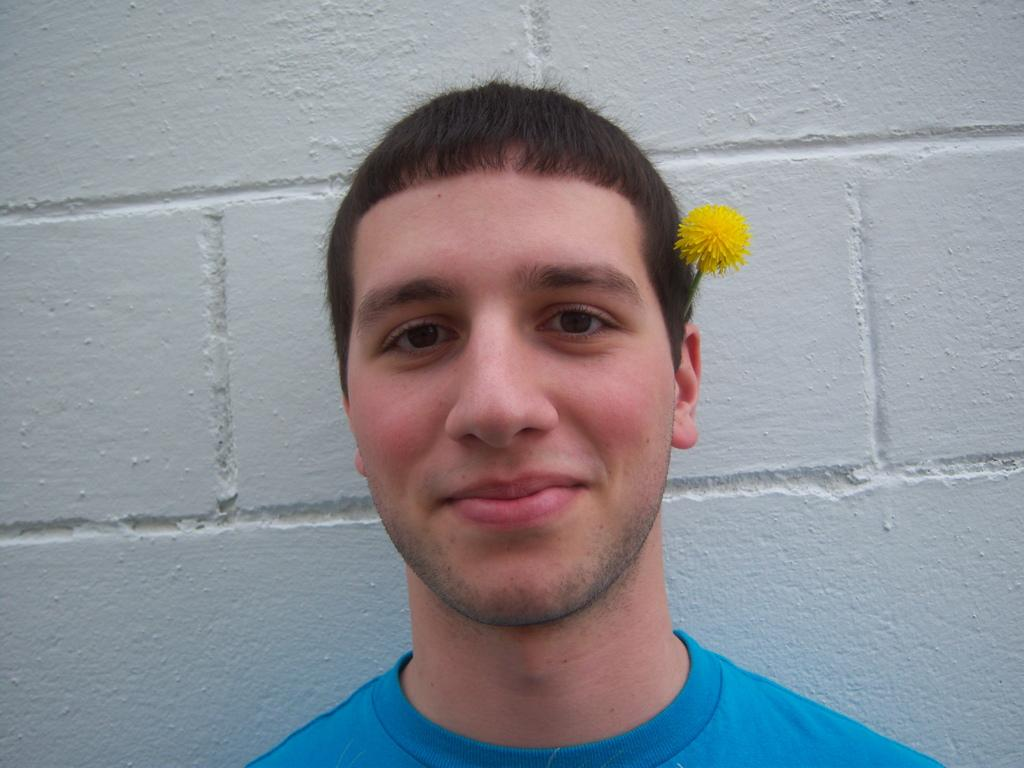Who is present in the image? There is a man in the image. What is the man doing in the image? The man is smiling in the image. Is there any accessory or decoration on the man? Yes, there is a flower on the man's ear. What can be seen in the background of the image? There is a wall in the background of the image. What type of grass can be seen growing on the man's shoulder in the image? There is no grass visible on the man's shoulder in the image. 